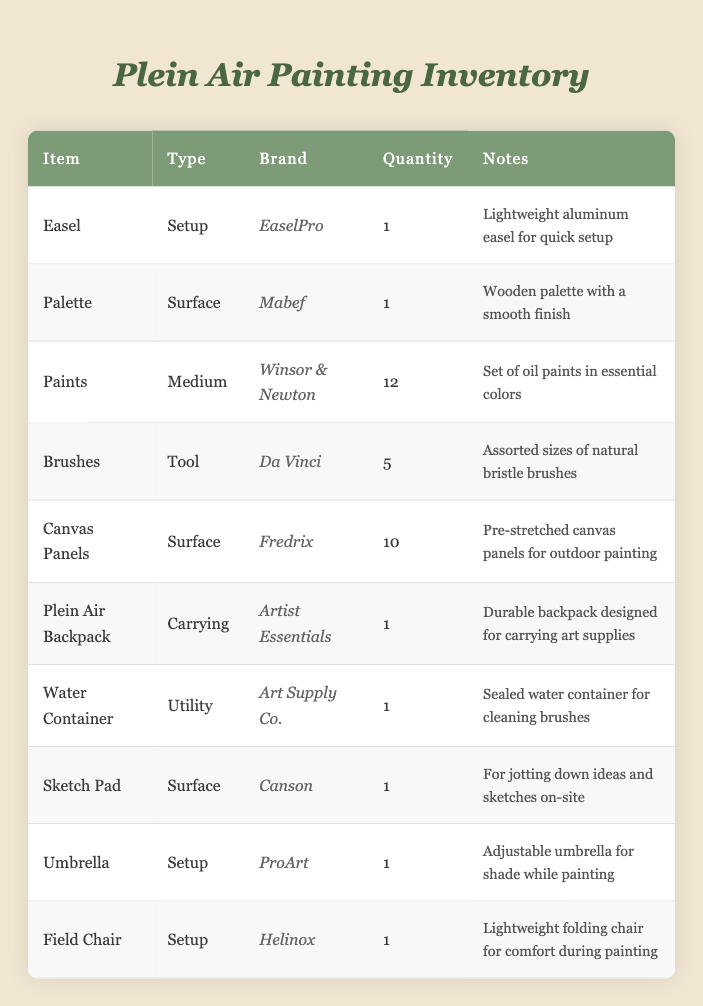What is the brand of the easel? The brand column lists different items and their corresponding brands. The easel is listed in the first row, and under the Brand column, it states "EaselPro."
Answer: EaselPro How many canvas panels are available? The quantity column indicates the number of each item available. In the row for canvas panels, the quantity listed is "10."
Answer: 10 Are there more brushes than paints in the inventory? To answer this, we can look at the quantity for brushes (5) and paints (12). Since 5 is less than 12, the statement is false.
Answer: No What type of item is the Plein Air Backpack? By checking the type column, the Plein Air Backpack is categorized as "Carrying."
Answer: Carrying If I would only like to paint using the medium and surface types, how many items are available in total? The items with medium types are “Paints” (1 item) and “Surface” (Canvas Panels, Palette, Sketch Pad = 3 items). Adding them gives 1 + 3 = 4.
Answer: 4 Is there any setup item that has more than one unit available? By reviewing the quantity column under the type "Setup," we see that all setup items (Easel, Umbrella, Field Chair) have a quantity of 1. Therefore, no setup item has more than one unit.
Answer: No Which items are designed for setup? The setup type items listed in the table include "Easel," "Umbrella," and "Field Chair." These can be found in the corresponding type column.
Answer: Easel, Umbrella, Field Chair What is the total number of different types of brushes and canvas panels available? The quantity of brushes is 5, and the canvas panels is 10. Summing these gives a total of 5 + 10 = 15.
Answer: 15 How many unique brands are listed in the inventory? Checking the brand column, we have the following unique brands: EaselPro, Mabef, Winsor & Newton, Da Vinci, Fredrix, Artist Essentials, Art Supply Co., Canson, ProArt, Helinox. There are 10 unique brands in total.
Answer: 10 